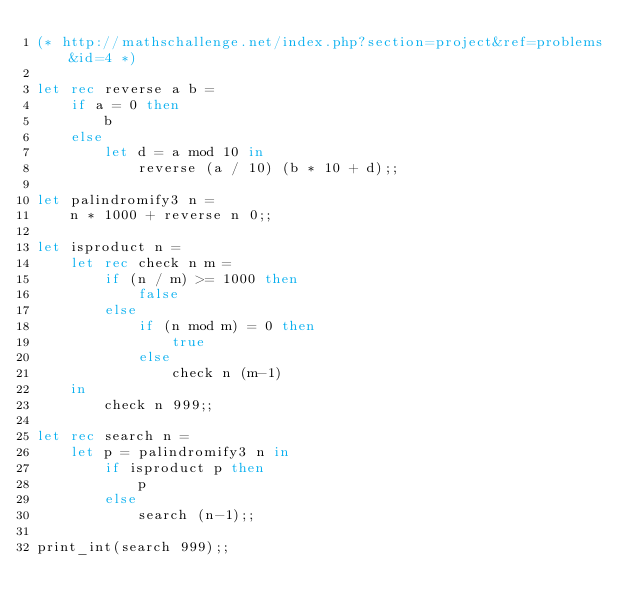<code> <loc_0><loc_0><loc_500><loc_500><_OCaml_>(* http://mathschallenge.net/index.php?section=project&ref=problems&id=4 *)

let rec reverse a b =
    if a = 0 then
        b
    else
        let d = a mod 10 in
            reverse (a / 10) (b * 10 + d);;

let palindromify3 n =
    n * 1000 + reverse n 0;;

let isproduct n =
    let rec check n m =
        if (n / m) >= 1000 then
            false
        else
            if (n mod m) = 0 then
                true
            else
                check n (m-1)
    in
        check n 999;;

let rec search n =
    let p = palindromify3 n in
        if isproduct p then
            p
        else
            search (n-1);;

print_int(search 999);;

</code> 